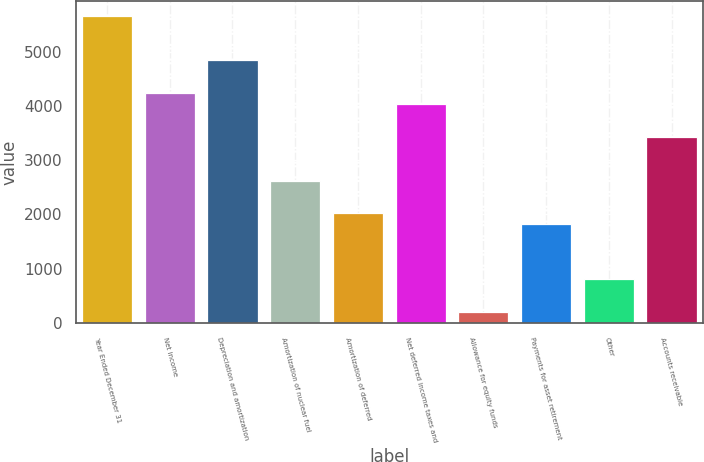Convert chart to OTSL. <chart><loc_0><loc_0><loc_500><loc_500><bar_chart><fcel>Year Ended December 31<fcel>Net income<fcel>Depreciation and amortization<fcel>Amortization of nuclear fuel<fcel>Amortization of deferred<fcel>Net deferred income taxes and<fcel>Allowance for equity funds<fcel>Payments for asset retirement<fcel>Other<fcel>Accounts receivable<nl><fcel>5649.68<fcel>4237.36<fcel>4842.64<fcel>2623.28<fcel>2018<fcel>4035.6<fcel>202.16<fcel>1816.24<fcel>807.44<fcel>3430.32<nl></chart> 